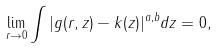Convert formula to latex. <formula><loc_0><loc_0><loc_500><loc_500>\lim _ { r \to 0 } \int | g ( r , z ) - k ( z ) | ^ { a , b } d z = 0 ,</formula> 